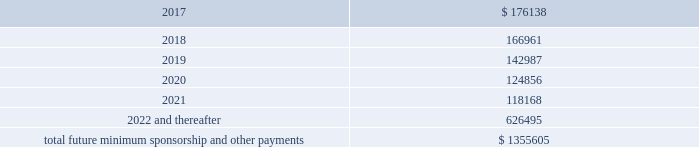2016 , as well as significant sponsorship and other marketing agreements entered into during the period after december 31 , 2016 through the date of this report : ( in thousands ) .
Total future minimum sponsorship and other payments $ 1355605 the amounts listed above are the minimum compensation obligations and guaranteed royalty fees required to be paid under the company 2019s sponsorship and other marketing agreements .
The amounts listed above do not include additional performance incentives and product supply obligations provided under certain agreements .
It is not possible to determine how much the company will spend on product supply obligations on an annual basis as contracts generally do not stipulate specific cash amounts to be spent on products .
The amount of product provided to the sponsorships depends on many factors including general playing conditions , the number of sporting events in which they participate and the company 2019s decisions regarding product and marketing initiatives .
In addition , the costs to design , develop , source and purchase the products furnished to the endorsers are incurred over a period of time and are not necessarily tracked separately from similar costs incurred for products sold to customers .
In connection with various contracts and agreements , the company has agreed to indemnify counterparties against certain third party claims relating to the infringement of intellectual property rights and other items .
Generally , such indemnification obligations do not apply in situations in which the counterparties are grossly negligent , engage in willful misconduct , or act in bad faith .
Based on the company 2019s historical experience and the estimated probability of future loss , the company has determined that the fair value of such indemnifications is not material to its consolidated financial position or results of operations .
From time to time , the company is involved in litigation and other proceedings , including matters related to commercial and intellectual property disputes , as well as trade , regulatory and other claims related to its business .
Other than as described below , the company believes that all current proceedings are routine in nature and incidental to the conduct of its business , and that the ultimate resolution of any such proceedings will not have a material adverse effect on its consolidated financial position , results of operations or cash flows .
On february 10 , 2017 , a shareholder filed a securities case in the united states district court for the district of maryland ( the 201ccourt 201d ) against the company , the company 2019s chief executive officer and the company 2019s former chief financial officer ( brian breece v .
Under armour , inc. ) .
On february 16 , 2017 , a second shareholder filed a securities case in the court against the same defendants ( jodie hopkins v .
Under armour , inc. ) .
The plaintiff in each case purports to represent a class of shareholders for the period between april 21 , 2016 and january 30 , 2017 , inclusive .
The complaints allege violations of section 10 ( b ) ( and rule 10b-5 ) of the securities exchange act of 1934 , as amended ( the 201cexchange act 201d ) and section 20 ( a ) control person liability under the exchange act against the officers named in the complaints .
In general , the allegations in each case concern disclosures and statements made by .
What percentage of total future minimum sponsorship and other payments are scheduled for 2018? 
Computations: (166961 / 1355605)
Answer: 0.12316. 2016 , as well as significant sponsorship and other marketing agreements entered into during the period after december 31 , 2016 through the date of this report : ( in thousands ) .
Total future minimum sponsorship and other payments $ 1355605 the amounts listed above are the minimum compensation obligations and guaranteed royalty fees required to be paid under the company 2019s sponsorship and other marketing agreements .
The amounts listed above do not include additional performance incentives and product supply obligations provided under certain agreements .
It is not possible to determine how much the company will spend on product supply obligations on an annual basis as contracts generally do not stipulate specific cash amounts to be spent on products .
The amount of product provided to the sponsorships depends on many factors including general playing conditions , the number of sporting events in which they participate and the company 2019s decisions regarding product and marketing initiatives .
In addition , the costs to design , develop , source and purchase the products furnished to the endorsers are incurred over a period of time and are not necessarily tracked separately from similar costs incurred for products sold to customers .
In connection with various contracts and agreements , the company has agreed to indemnify counterparties against certain third party claims relating to the infringement of intellectual property rights and other items .
Generally , such indemnification obligations do not apply in situations in which the counterparties are grossly negligent , engage in willful misconduct , or act in bad faith .
Based on the company 2019s historical experience and the estimated probability of future loss , the company has determined that the fair value of such indemnifications is not material to its consolidated financial position or results of operations .
From time to time , the company is involved in litigation and other proceedings , including matters related to commercial and intellectual property disputes , as well as trade , regulatory and other claims related to its business .
Other than as described below , the company believes that all current proceedings are routine in nature and incidental to the conduct of its business , and that the ultimate resolution of any such proceedings will not have a material adverse effect on its consolidated financial position , results of operations or cash flows .
On february 10 , 2017 , a shareholder filed a securities case in the united states district court for the district of maryland ( the 201ccourt 201d ) against the company , the company 2019s chief executive officer and the company 2019s former chief financial officer ( brian breece v .
Under armour , inc. ) .
On february 16 , 2017 , a second shareholder filed a securities case in the court against the same defendants ( jodie hopkins v .
Under armour , inc. ) .
The plaintiff in each case purports to represent a class of shareholders for the period between april 21 , 2016 and january 30 , 2017 , inclusive .
The complaints allege violations of section 10 ( b ) ( and rule 10b-5 ) of the securities exchange act of 1934 , as amended ( the 201cexchange act 201d ) and section 20 ( a ) control person liability under the exchange act against the officers named in the complaints .
In general , the allegations in each case concern disclosures and statements made by .
What percentage of total future minimum sponsorship and other payments are scheduled for 2019? 
Computations: (142987 / 1355605)
Answer: 0.10548. 